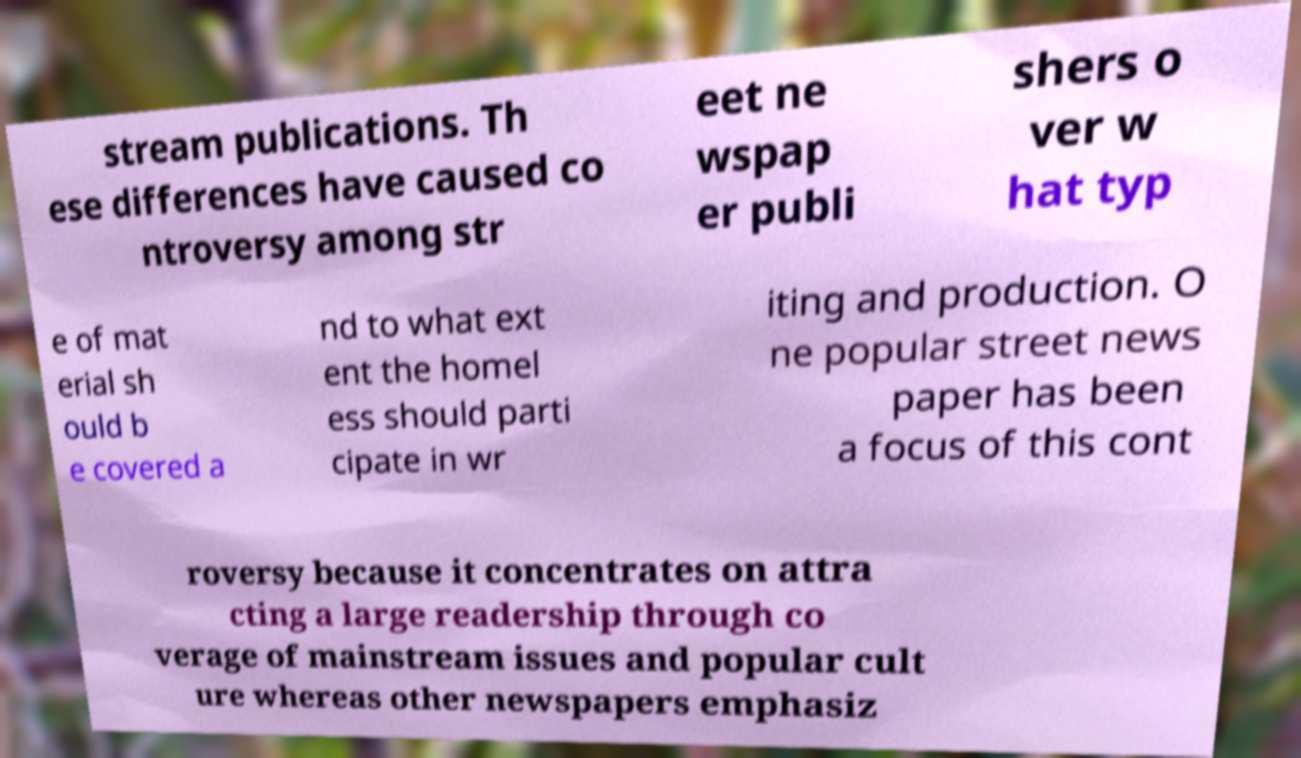Please read and relay the text visible in this image. What does it say? stream publications. Th ese differences have caused co ntroversy among str eet ne wspap er publi shers o ver w hat typ e of mat erial sh ould b e covered a nd to what ext ent the homel ess should parti cipate in wr iting and production. O ne popular street news paper has been a focus of this cont roversy because it concentrates on attra cting a large readership through co verage of mainstream issues and popular cult ure whereas other newspapers emphasiz 